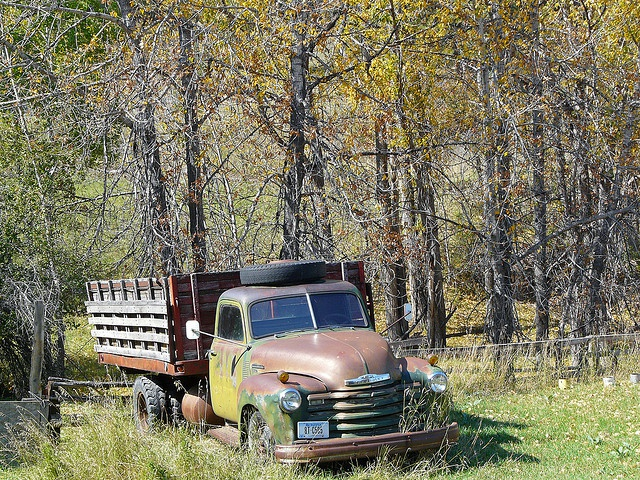Describe the objects in this image and their specific colors. I can see a truck in lightgreen, black, darkgray, lightgray, and gray tones in this image. 